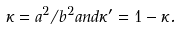<formula> <loc_0><loc_0><loc_500><loc_500>\kappa = a ^ { 2 } / b ^ { 2 } a n d \kappa ^ { \prime } = 1 - \kappa .</formula> 